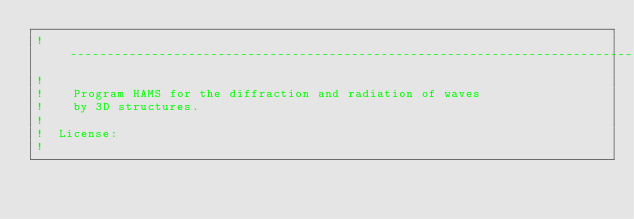<code> <loc_0><loc_0><loc_500><loc_500><_FORTRAN_>!  ------------------------------------------------------------------------------------------------------
!                                                               
!    Program HAMS for the diffraction and radiation of waves 
!    by 3D structures.
! 
!  License:
! </code> 